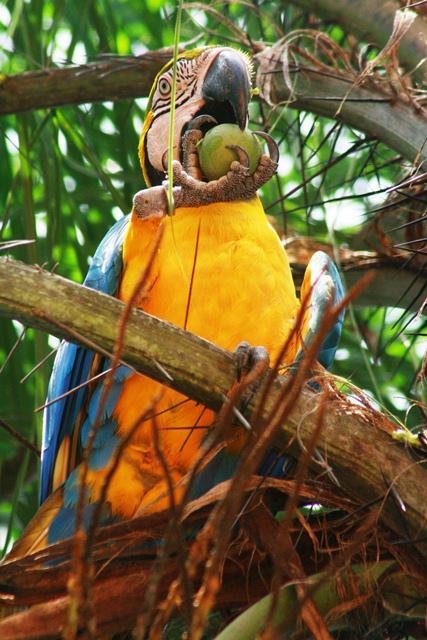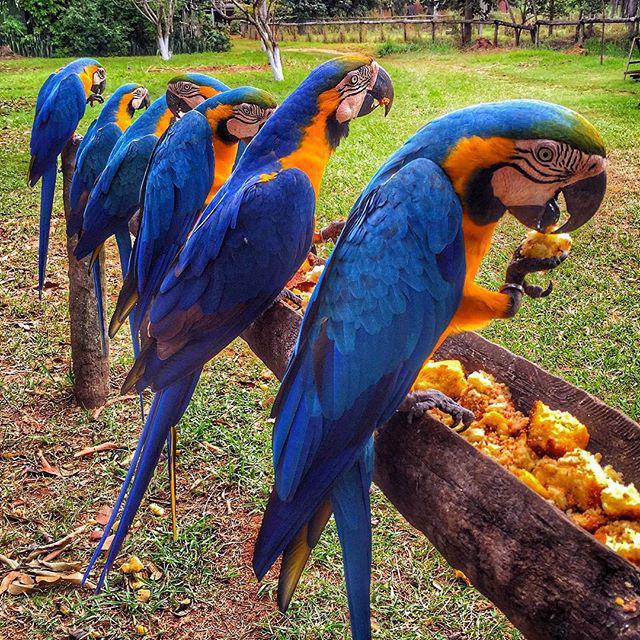The first image is the image on the left, the second image is the image on the right. For the images displayed, is the sentence "The right image features at least six blue parrots." factually correct? Answer yes or no. Yes. 